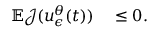<formula> <loc_0><loc_0><loc_500><loc_500>\begin{array} { r l } { \mathbb { E } \mathcal { J } ( u _ { \epsilon } ^ { \theta } ( t ) ) } & \leq 0 . } \end{array}</formula> 